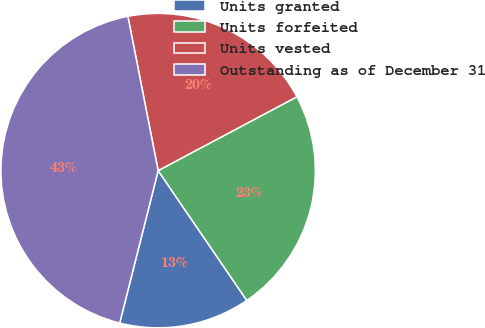Convert chart. <chart><loc_0><loc_0><loc_500><loc_500><pie_chart><fcel>Units granted<fcel>Units forfeited<fcel>Units vested<fcel>Outstanding as of December 31<nl><fcel>13.47%<fcel>23.25%<fcel>20.3%<fcel>42.99%<nl></chart> 